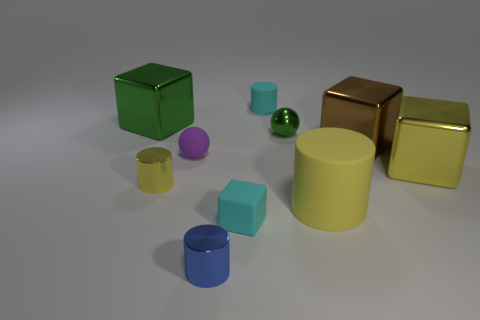Subtract all small matte cylinders. How many cylinders are left? 3 Subtract all yellow spheres. How many yellow cylinders are left? 2 Subtract all purple spheres. How many spheres are left? 1 Add 7 cyan cylinders. How many cyan cylinders are left? 8 Add 3 small brown blocks. How many small brown blocks exist? 3 Subtract 1 yellow cubes. How many objects are left? 9 Subtract all cubes. How many objects are left? 6 Subtract 3 cylinders. How many cylinders are left? 1 Subtract all red balls. Subtract all red cylinders. How many balls are left? 2 Subtract all metallic objects. Subtract all small shiny objects. How many objects are left? 1 